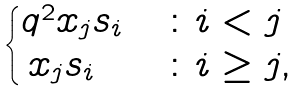Convert formula to latex. <formula><loc_0><loc_0><loc_500><loc_500>\begin{cases} q ^ { 2 } x _ { j } s _ { i } & \colon i < j \\ \, x _ { j } s _ { i } & \colon i \geq j , \end{cases}</formula> 